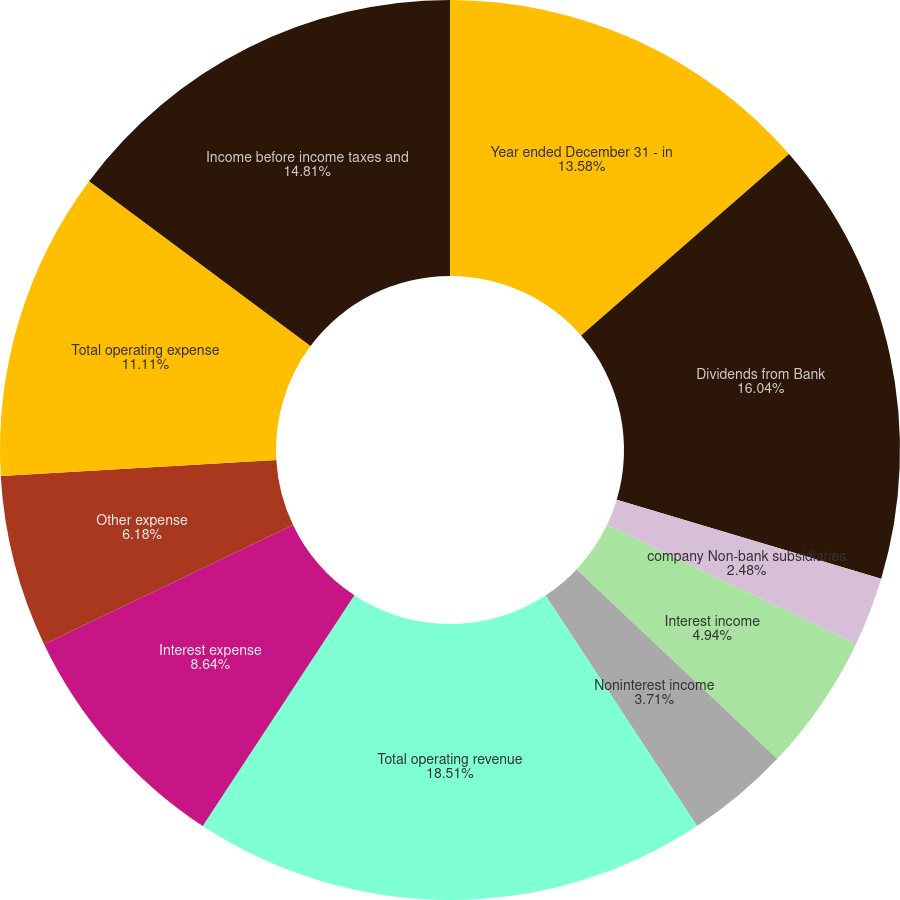Convert chart to OTSL. <chart><loc_0><loc_0><loc_500><loc_500><pie_chart><fcel>Year ended December 31 - in<fcel>Dividends from Bank<fcel>company Non-bank subsidiaries<fcel>Interest income<fcel>Noninterest income<fcel>Total operating revenue<fcel>Interest expense<fcel>Other expense<fcel>Total operating expense<fcel>Income before income taxes and<nl><fcel>13.58%<fcel>16.04%<fcel>2.48%<fcel>4.94%<fcel>3.71%<fcel>18.51%<fcel>8.64%<fcel>6.18%<fcel>11.11%<fcel>14.81%<nl></chart> 